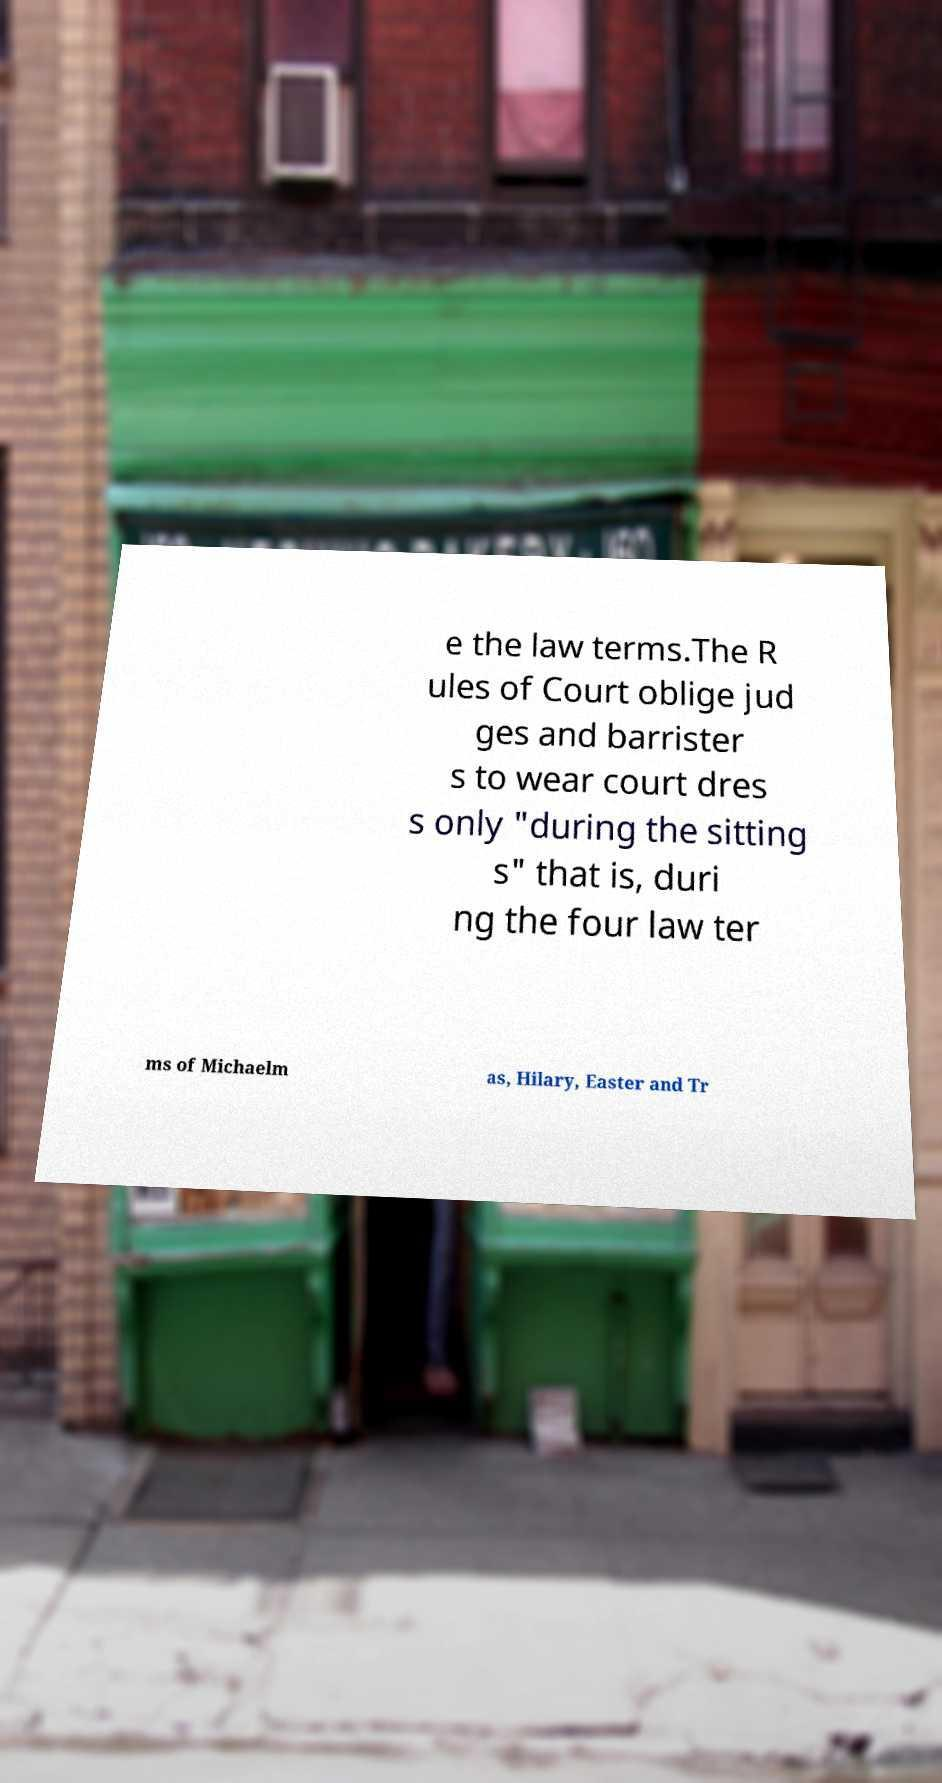Can you accurately transcribe the text from the provided image for me? e the law terms.The R ules of Court oblige jud ges and barrister s to wear court dres s only "during the sitting s" that is, duri ng the four law ter ms of Michaelm as, Hilary, Easter and Tr 